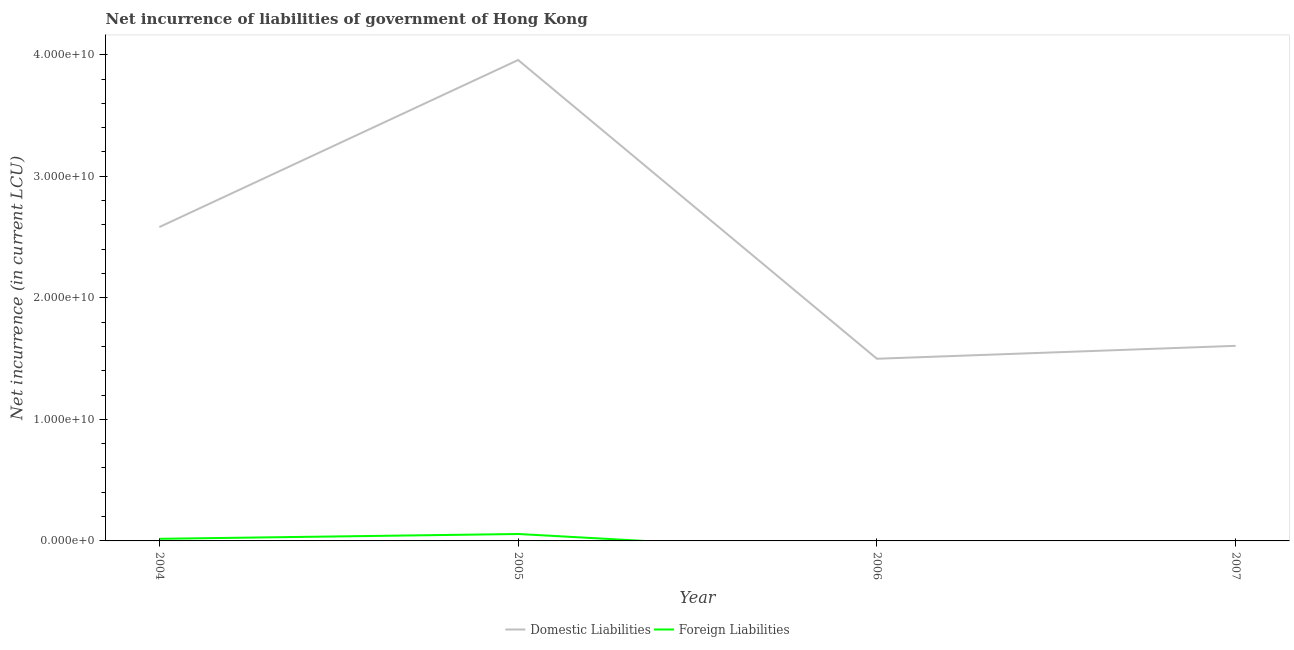Does the line corresponding to net incurrence of foreign liabilities intersect with the line corresponding to net incurrence of domestic liabilities?
Make the answer very short. No. Across all years, what is the maximum net incurrence of domestic liabilities?
Keep it short and to the point. 3.96e+1. Across all years, what is the minimum net incurrence of domestic liabilities?
Offer a terse response. 1.50e+1. In which year was the net incurrence of domestic liabilities maximum?
Your answer should be compact. 2005. What is the total net incurrence of foreign liabilities in the graph?
Provide a succinct answer. 7.44e+08. What is the difference between the net incurrence of domestic liabilities in 2004 and that in 2005?
Your answer should be very brief. -1.37e+1. What is the difference between the net incurrence of domestic liabilities in 2004 and the net incurrence of foreign liabilities in 2007?
Your response must be concise. 2.58e+1. What is the average net incurrence of domestic liabilities per year?
Provide a succinct answer. 2.41e+1. In the year 2004, what is the difference between the net incurrence of foreign liabilities and net incurrence of domestic liabilities?
Your answer should be very brief. -2.56e+1. What is the ratio of the net incurrence of domestic liabilities in 2005 to that in 2006?
Provide a short and direct response. 2.64. Is the net incurrence of domestic liabilities in 2004 less than that in 2006?
Give a very brief answer. No. Is the difference between the net incurrence of domestic liabilities in 2004 and 2005 greater than the difference between the net incurrence of foreign liabilities in 2004 and 2005?
Your answer should be compact. No. What is the difference between the highest and the second highest net incurrence of domestic liabilities?
Offer a very short reply. 1.37e+1. What is the difference between the highest and the lowest net incurrence of domestic liabilities?
Provide a succinct answer. 2.46e+1. Is the net incurrence of domestic liabilities strictly less than the net incurrence of foreign liabilities over the years?
Ensure brevity in your answer.  No. How many lines are there?
Provide a short and direct response. 2. How many years are there in the graph?
Keep it short and to the point. 4. What is the title of the graph?
Offer a very short reply. Net incurrence of liabilities of government of Hong Kong. What is the label or title of the X-axis?
Ensure brevity in your answer.  Year. What is the label or title of the Y-axis?
Keep it short and to the point. Net incurrence (in current LCU). What is the Net incurrence (in current LCU) of Domestic Liabilities in 2004?
Offer a terse response. 2.58e+1. What is the Net incurrence (in current LCU) in Foreign Liabilities in 2004?
Provide a succinct answer. 1.74e+08. What is the Net incurrence (in current LCU) in Domestic Liabilities in 2005?
Give a very brief answer. 3.96e+1. What is the Net incurrence (in current LCU) of Foreign Liabilities in 2005?
Offer a terse response. 5.70e+08. What is the Net incurrence (in current LCU) in Domestic Liabilities in 2006?
Provide a short and direct response. 1.50e+1. What is the Net incurrence (in current LCU) of Domestic Liabilities in 2007?
Provide a short and direct response. 1.61e+1. Across all years, what is the maximum Net incurrence (in current LCU) in Domestic Liabilities?
Provide a short and direct response. 3.96e+1. Across all years, what is the maximum Net incurrence (in current LCU) in Foreign Liabilities?
Ensure brevity in your answer.  5.70e+08. Across all years, what is the minimum Net incurrence (in current LCU) in Domestic Liabilities?
Provide a short and direct response. 1.50e+1. Across all years, what is the minimum Net incurrence (in current LCU) in Foreign Liabilities?
Offer a very short reply. 0. What is the total Net incurrence (in current LCU) of Domestic Liabilities in the graph?
Give a very brief answer. 9.64e+1. What is the total Net incurrence (in current LCU) in Foreign Liabilities in the graph?
Your answer should be very brief. 7.44e+08. What is the difference between the Net incurrence (in current LCU) of Domestic Liabilities in 2004 and that in 2005?
Your answer should be very brief. -1.37e+1. What is the difference between the Net incurrence (in current LCU) of Foreign Liabilities in 2004 and that in 2005?
Make the answer very short. -3.96e+08. What is the difference between the Net incurrence (in current LCU) of Domestic Liabilities in 2004 and that in 2006?
Your answer should be compact. 1.08e+1. What is the difference between the Net incurrence (in current LCU) in Domestic Liabilities in 2004 and that in 2007?
Offer a terse response. 9.77e+09. What is the difference between the Net incurrence (in current LCU) in Domestic Liabilities in 2005 and that in 2006?
Keep it short and to the point. 2.46e+1. What is the difference between the Net incurrence (in current LCU) in Domestic Liabilities in 2005 and that in 2007?
Offer a terse response. 2.35e+1. What is the difference between the Net incurrence (in current LCU) of Domestic Liabilities in 2006 and that in 2007?
Your answer should be very brief. -1.06e+09. What is the difference between the Net incurrence (in current LCU) in Domestic Liabilities in 2004 and the Net incurrence (in current LCU) in Foreign Liabilities in 2005?
Your answer should be very brief. 2.53e+1. What is the average Net incurrence (in current LCU) of Domestic Liabilities per year?
Provide a succinct answer. 2.41e+1. What is the average Net incurrence (in current LCU) of Foreign Liabilities per year?
Give a very brief answer. 1.86e+08. In the year 2004, what is the difference between the Net incurrence (in current LCU) of Domestic Liabilities and Net incurrence (in current LCU) of Foreign Liabilities?
Ensure brevity in your answer.  2.56e+1. In the year 2005, what is the difference between the Net incurrence (in current LCU) of Domestic Liabilities and Net incurrence (in current LCU) of Foreign Liabilities?
Offer a terse response. 3.90e+1. What is the ratio of the Net incurrence (in current LCU) in Domestic Liabilities in 2004 to that in 2005?
Your answer should be compact. 0.65. What is the ratio of the Net incurrence (in current LCU) in Foreign Liabilities in 2004 to that in 2005?
Your response must be concise. 0.31. What is the ratio of the Net incurrence (in current LCU) in Domestic Liabilities in 2004 to that in 2006?
Your response must be concise. 1.72. What is the ratio of the Net incurrence (in current LCU) of Domestic Liabilities in 2004 to that in 2007?
Your response must be concise. 1.61. What is the ratio of the Net incurrence (in current LCU) of Domestic Liabilities in 2005 to that in 2006?
Offer a terse response. 2.64. What is the ratio of the Net incurrence (in current LCU) in Domestic Liabilities in 2005 to that in 2007?
Your response must be concise. 2.47. What is the ratio of the Net incurrence (in current LCU) of Domestic Liabilities in 2006 to that in 2007?
Your response must be concise. 0.93. What is the difference between the highest and the second highest Net incurrence (in current LCU) in Domestic Liabilities?
Provide a short and direct response. 1.37e+1. What is the difference between the highest and the lowest Net incurrence (in current LCU) of Domestic Liabilities?
Keep it short and to the point. 2.46e+1. What is the difference between the highest and the lowest Net incurrence (in current LCU) in Foreign Liabilities?
Your response must be concise. 5.70e+08. 